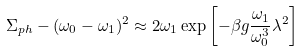Convert formula to latex. <formula><loc_0><loc_0><loc_500><loc_500>\Sigma _ { p h } - ( \omega _ { 0 } - \omega _ { 1 } ) ^ { 2 } \approx 2 \omega _ { 1 } \exp { \left [ - \beta g { \frac { \omega _ { 1 } } { \omega _ { 0 } ^ { 3 } } } \lambda ^ { 2 } \right ] }</formula> 